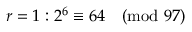Convert formula to latex. <formula><loc_0><loc_0><loc_500><loc_500>r = 1 \colon 2 ^ { 6 } \equiv 6 4 { \pmod { 9 7 } }</formula> 